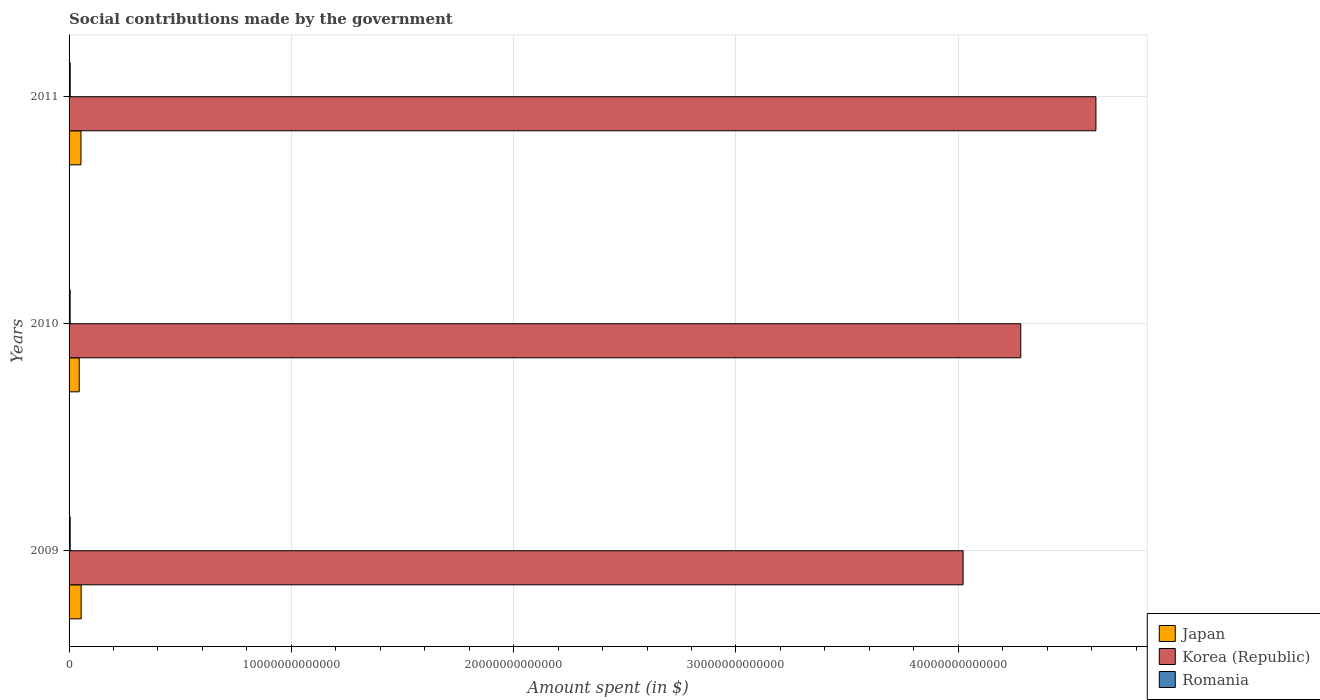How many bars are there on the 3rd tick from the top?
Your response must be concise. 3. How many bars are there on the 3rd tick from the bottom?
Give a very brief answer. 3. What is the label of the 1st group of bars from the top?
Provide a short and direct response. 2011. In how many cases, is the number of bars for a given year not equal to the number of legend labels?
Give a very brief answer. 0. What is the amount spent on social contributions in Romania in 2010?
Your answer should be compact. 4.85e+1. Across all years, what is the maximum amount spent on social contributions in Korea (Republic)?
Your answer should be very brief. 4.62e+13. Across all years, what is the minimum amount spent on social contributions in Romania?
Your answer should be compact. 4.85e+1. In which year was the amount spent on social contributions in Korea (Republic) minimum?
Your answer should be compact. 2009. What is the total amount spent on social contributions in Korea (Republic) in the graph?
Ensure brevity in your answer.  1.29e+14. What is the difference between the amount spent on social contributions in Korea (Republic) in 2009 and that in 2010?
Keep it short and to the point. -2.59e+12. What is the difference between the amount spent on social contributions in Korea (Republic) in 2010 and the amount spent on social contributions in Japan in 2011?
Offer a terse response. 4.23e+13. What is the average amount spent on social contributions in Korea (Republic) per year?
Provide a short and direct response. 4.31e+13. In the year 2011, what is the difference between the amount spent on social contributions in Romania and amount spent on social contributions in Korea (Republic)?
Keep it short and to the point. -4.61e+13. In how many years, is the amount spent on social contributions in Japan greater than 26000000000000 $?
Your answer should be compact. 0. What is the ratio of the amount spent on social contributions in Japan in 2009 to that in 2010?
Provide a short and direct response. 1.19. What is the difference between the highest and the second highest amount spent on social contributions in Korea (Republic)?
Keep it short and to the point. 3.38e+12. What is the difference between the highest and the lowest amount spent on social contributions in Romania?
Give a very brief answer. 2.01e+09. What does the 1st bar from the top in 2011 represents?
Keep it short and to the point. Romania. What does the 2nd bar from the bottom in 2009 represents?
Your answer should be very brief. Korea (Republic). Is it the case that in every year, the sum of the amount spent on social contributions in Korea (Republic) and amount spent on social contributions in Japan is greater than the amount spent on social contributions in Romania?
Provide a succinct answer. Yes. How many bars are there?
Your answer should be compact. 9. Are all the bars in the graph horizontal?
Your response must be concise. Yes. How many years are there in the graph?
Your response must be concise. 3. What is the difference between two consecutive major ticks on the X-axis?
Your answer should be compact. 1.00e+13. Are the values on the major ticks of X-axis written in scientific E-notation?
Your answer should be compact. No. Does the graph contain any zero values?
Offer a terse response. No. Where does the legend appear in the graph?
Keep it short and to the point. Bottom right. How many legend labels are there?
Keep it short and to the point. 3. How are the legend labels stacked?
Ensure brevity in your answer.  Vertical. What is the title of the graph?
Ensure brevity in your answer.  Social contributions made by the government. Does "Sri Lanka" appear as one of the legend labels in the graph?
Your answer should be compact. No. What is the label or title of the X-axis?
Your answer should be compact. Amount spent (in $). What is the label or title of the Y-axis?
Keep it short and to the point. Years. What is the Amount spent (in $) in Japan in 2009?
Your answer should be compact. 5.44e+11. What is the Amount spent (in $) of Korea (Republic) in 2009?
Provide a succinct answer. 4.02e+13. What is the Amount spent (in $) in Romania in 2009?
Make the answer very short. 4.96e+1. What is the Amount spent (in $) in Japan in 2010?
Your response must be concise. 4.58e+11. What is the Amount spent (in $) in Korea (Republic) in 2010?
Make the answer very short. 4.28e+13. What is the Amount spent (in $) of Romania in 2010?
Provide a succinct answer. 4.85e+1. What is the Amount spent (in $) in Japan in 2011?
Provide a short and direct response. 5.35e+11. What is the Amount spent (in $) of Korea (Republic) in 2011?
Keep it short and to the point. 4.62e+13. What is the Amount spent (in $) in Romania in 2011?
Ensure brevity in your answer.  5.05e+1. Across all years, what is the maximum Amount spent (in $) in Japan?
Keep it short and to the point. 5.44e+11. Across all years, what is the maximum Amount spent (in $) in Korea (Republic)?
Keep it short and to the point. 4.62e+13. Across all years, what is the maximum Amount spent (in $) in Romania?
Offer a very short reply. 5.05e+1. Across all years, what is the minimum Amount spent (in $) of Japan?
Your answer should be very brief. 4.58e+11. Across all years, what is the minimum Amount spent (in $) of Korea (Republic)?
Ensure brevity in your answer.  4.02e+13. Across all years, what is the minimum Amount spent (in $) of Romania?
Ensure brevity in your answer.  4.85e+1. What is the total Amount spent (in $) of Japan in the graph?
Provide a succinct answer. 1.54e+12. What is the total Amount spent (in $) in Korea (Republic) in the graph?
Offer a terse response. 1.29e+14. What is the total Amount spent (in $) in Romania in the graph?
Your response must be concise. 1.49e+11. What is the difference between the Amount spent (in $) in Japan in 2009 and that in 2010?
Keep it short and to the point. 8.60e+1. What is the difference between the Amount spent (in $) in Korea (Republic) in 2009 and that in 2010?
Your answer should be very brief. -2.59e+12. What is the difference between the Amount spent (in $) in Romania in 2009 and that in 2010?
Your answer should be very brief. 1.09e+09. What is the difference between the Amount spent (in $) of Japan in 2009 and that in 2011?
Offer a terse response. 8.10e+09. What is the difference between the Amount spent (in $) of Korea (Republic) in 2009 and that in 2011?
Your answer should be very brief. -5.97e+12. What is the difference between the Amount spent (in $) in Romania in 2009 and that in 2011?
Offer a very short reply. -9.14e+08. What is the difference between the Amount spent (in $) in Japan in 2010 and that in 2011?
Provide a succinct answer. -7.79e+1. What is the difference between the Amount spent (in $) in Korea (Republic) in 2010 and that in 2011?
Give a very brief answer. -3.38e+12. What is the difference between the Amount spent (in $) in Romania in 2010 and that in 2011?
Offer a terse response. -2.01e+09. What is the difference between the Amount spent (in $) of Japan in 2009 and the Amount spent (in $) of Korea (Republic) in 2010?
Your answer should be very brief. -4.23e+13. What is the difference between the Amount spent (in $) of Japan in 2009 and the Amount spent (in $) of Romania in 2010?
Your answer should be compact. 4.95e+11. What is the difference between the Amount spent (in $) in Korea (Republic) in 2009 and the Amount spent (in $) in Romania in 2010?
Keep it short and to the point. 4.02e+13. What is the difference between the Amount spent (in $) in Japan in 2009 and the Amount spent (in $) in Korea (Republic) in 2011?
Your answer should be compact. -4.57e+13. What is the difference between the Amount spent (in $) of Japan in 2009 and the Amount spent (in $) of Romania in 2011?
Give a very brief answer. 4.93e+11. What is the difference between the Amount spent (in $) in Korea (Republic) in 2009 and the Amount spent (in $) in Romania in 2011?
Your response must be concise. 4.02e+13. What is the difference between the Amount spent (in $) in Japan in 2010 and the Amount spent (in $) in Korea (Republic) in 2011?
Ensure brevity in your answer.  -4.57e+13. What is the difference between the Amount spent (in $) of Japan in 2010 and the Amount spent (in $) of Romania in 2011?
Ensure brevity in your answer.  4.07e+11. What is the difference between the Amount spent (in $) of Korea (Republic) in 2010 and the Amount spent (in $) of Romania in 2011?
Offer a terse response. 4.28e+13. What is the average Amount spent (in $) of Japan per year?
Provide a succinct answer. 5.12e+11. What is the average Amount spent (in $) in Korea (Republic) per year?
Keep it short and to the point. 4.31e+13. What is the average Amount spent (in $) in Romania per year?
Provide a succinct answer. 4.95e+1. In the year 2009, what is the difference between the Amount spent (in $) in Japan and Amount spent (in $) in Korea (Republic)?
Provide a succinct answer. -3.97e+13. In the year 2009, what is the difference between the Amount spent (in $) of Japan and Amount spent (in $) of Romania?
Ensure brevity in your answer.  4.94e+11. In the year 2009, what is the difference between the Amount spent (in $) in Korea (Republic) and Amount spent (in $) in Romania?
Your answer should be compact. 4.02e+13. In the year 2010, what is the difference between the Amount spent (in $) in Japan and Amount spent (in $) in Korea (Republic)?
Give a very brief answer. -4.24e+13. In the year 2010, what is the difference between the Amount spent (in $) in Japan and Amount spent (in $) in Romania?
Offer a very short reply. 4.09e+11. In the year 2010, what is the difference between the Amount spent (in $) in Korea (Republic) and Amount spent (in $) in Romania?
Ensure brevity in your answer.  4.28e+13. In the year 2011, what is the difference between the Amount spent (in $) of Japan and Amount spent (in $) of Korea (Republic)?
Offer a very short reply. -4.57e+13. In the year 2011, what is the difference between the Amount spent (in $) of Japan and Amount spent (in $) of Romania?
Give a very brief answer. 4.85e+11. In the year 2011, what is the difference between the Amount spent (in $) in Korea (Republic) and Amount spent (in $) in Romania?
Provide a short and direct response. 4.61e+13. What is the ratio of the Amount spent (in $) in Japan in 2009 to that in 2010?
Offer a very short reply. 1.19. What is the ratio of the Amount spent (in $) in Korea (Republic) in 2009 to that in 2010?
Offer a very short reply. 0.94. What is the ratio of the Amount spent (in $) in Romania in 2009 to that in 2010?
Give a very brief answer. 1.02. What is the ratio of the Amount spent (in $) in Japan in 2009 to that in 2011?
Provide a succinct answer. 1.02. What is the ratio of the Amount spent (in $) in Korea (Republic) in 2009 to that in 2011?
Provide a short and direct response. 0.87. What is the ratio of the Amount spent (in $) in Romania in 2009 to that in 2011?
Offer a terse response. 0.98. What is the ratio of the Amount spent (in $) of Japan in 2010 to that in 2011?
Your answer should be very brief. 0.85. What is the ratio of the Amount spent (in $) in Korea (Republic) in 2010 to that in 2011?
Provide a succinct answer. 0.93. What is the ratio of the Amount spent (in $) of Romania in 2010 to that in 2011?
Ensure brevity in your answer.  0.96. What is the difference between the highest and the second highest Amount spent (in $) in Japan?
Offer a very short reply. 8.10e+09. What is the difference between the highest and the second highest Amount spent (in $) in Korea (Republic)?
Make the answer very short. 3.38e+12. What is the difference between the highest and the second highest Amount spent (in $) in Romania?
Offer a terse response. 9.14e+08. What is the difference between the highest and the lowest Amount spent (in $) in Japan?
Your answer should be very brief. 8.60e+1. What is the difference between the highest and the lowest Amount spent (in $) in Korea (Republic)?
Ensure brevity in your answer.  5.97e+12. What is the difference between the highest and the lowest Amount spent (in $) of Romania?
Your answer should be compact. 2.01e+09. 